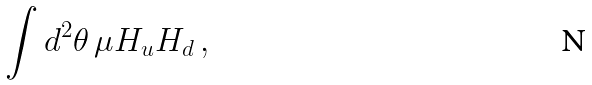<formula> <loc_0><loc_0><loc_500><loc_500>\int d ^ { 2 } \theta \, \mu H _ { u } H _ { d } \, ,</formula> 